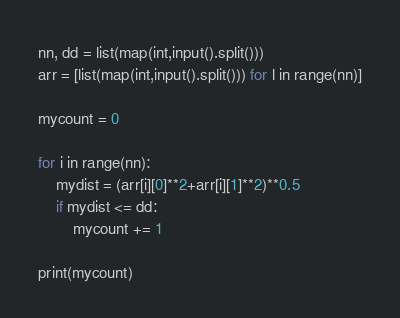Convert code to text. <code><loc_0><loc_0><loc_500><loc_500><_Python_>nn, dd = list(map(int,input().split()))
arr = [list(map(int,input().split())) for l in range(nn)]

mycount = 0

for i in range(nn):
    mydist = (arr[i][0]**2+arr[i][1]**2)**0.5
    if mydist <= dd:
        mycount += 1

print(mycount)</code> 